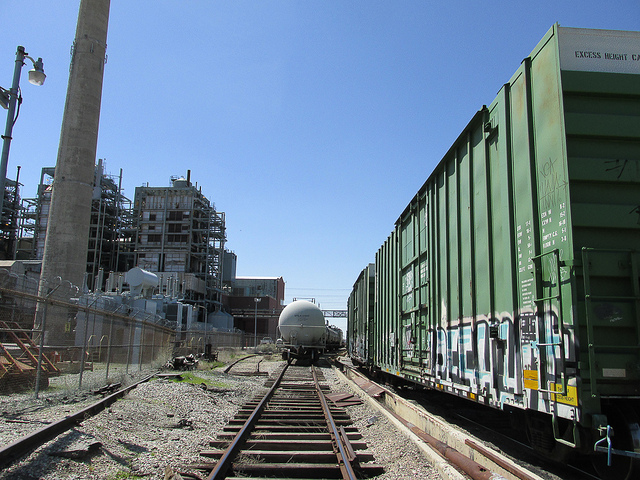<image>What fuel does the train run on? It is unsure what fuel the train runs on. It may run on gas, propane, coal or diesel. What fuel does the train run on? I am not sure what fuel the train runs on. It can be either gas, propane, coal, or diesel. 